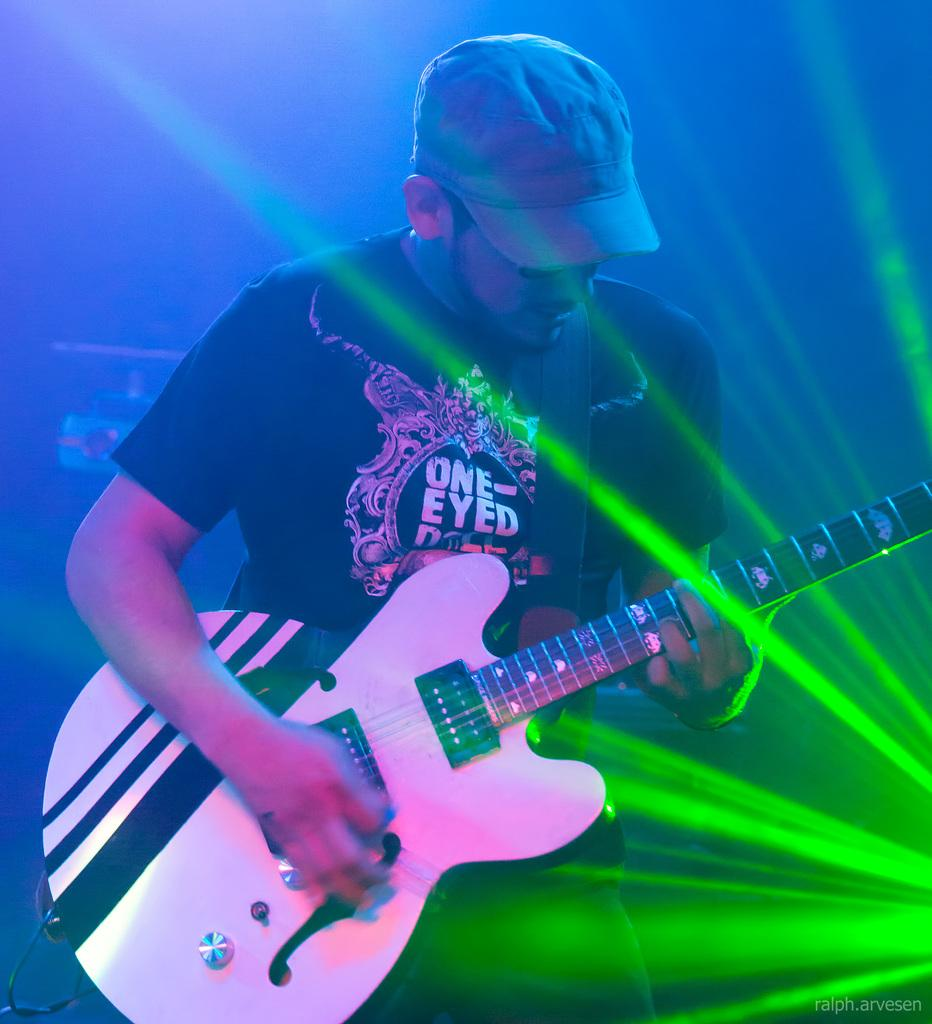What is the main subject of the image? The main subject of the image is a man standing in the middle. What is the man holding in the image? The man is holding a guitar. Can you describe the man's clothing in the image? The man is wearing a cap and a t-shirt. Where is the clover located in the image? There is no clover present in the image. What type of kettle is being used by the man in the image? There is no kettle present in the image; the man is holding a guitar. 